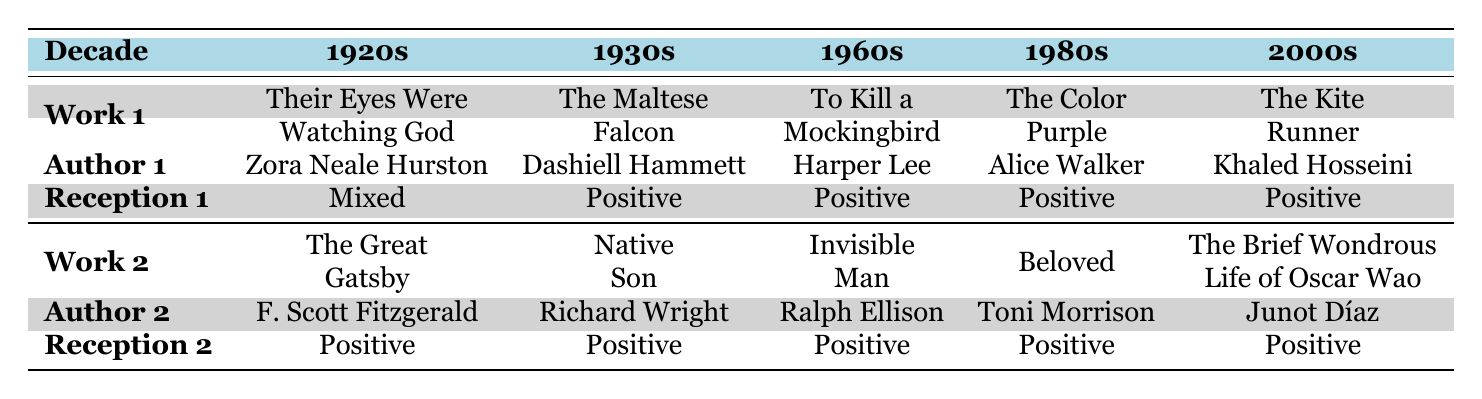What was the critical reception of "Their Eyes Were Watching God"? The table states that "Their Eyes Were Watching God," written by Zora Neale Hurston in the 1920s, received a mixed critical reception. This information can be directly retrieved from the corresponding row and column of the table.
Answer: Mixed Which author wrote the novel "Beloved"? According to the table, "Beloved" is authored by Toni Morrison. This is found in the 1980s column under the Works section of the table.
Answer: Toni Morrison Did any works in the 1930s receive a mixed critical reception? The table shows that both works listed in the 1930s, "The Maltese Falcon" and "Native Son," received a positive critical reception, meaning there were no mixed receptions in that decade. This is assessed by checking the critical reception values for the 1930s row.
Answer: No How many works were positively received across all decades? Counting the number of positively received works: "The Great Gatsby," "The Maltese Falcon," "Native Son," "To Kill a Mockingbird," "Invisible Man," "The Color Purple," "Beloved," "The Kite Runner," and "The Brief Wondrous Life of Oscar Wao" gives a total of 9 positively received works. This involves summing the positive receptions indicated in each corresponding decade.
Answer: 9 Which decade featured a work with mixed critical reception? From the table, only the 1920s decade has a work, "Their Eyes Were Watching God," that received mixed critical reception, as indicated in the corresponding reception row. Therefore, it is the only decade to feature this type of reception.
Answer: 1920s What is the percentage of works with positive critical reception in the 1960s? In the 1960s, both works listed, "To Kill a Mockingbird" and "Invisible Man," received positive receptions, yielding a percentage of 100% for positive critical reception in that decade. The calculation is (2 positive works / 2 total works) * 100 = 100%.
Answer: 100% Is it true that all works from the 2000s were positively received? The table shows that both "The Kite Runner" and "The Brief Wondrous Life of Oscar Wao," published in the 2000s, were positively received. Thus, the statement can be confirmed as true by referencing the critical reception entries for that decade.
Answer: Yes Which decade had the highest number of works listed? The table shows that there are 2 works listed for each decade, making it equal across all decades presented. Hence, no decade stands out with a higher number of works. This is determined by counting the works in each decade and comparing totals.
Answer: None (all equal) 